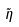Convert formula to latex. <formula><loc_0><loc_0><loc_500><loc_500>\tilde { \eta }</formula> 